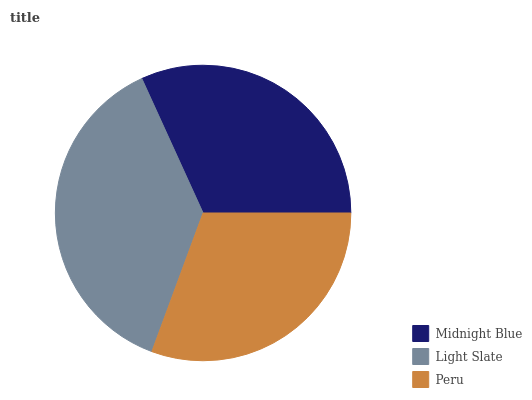Is Peru the minimum?
Answer yes or no. Yes. Is Light Slate the maximum?
Answer yes or no. Yes. Is Light Slate the minimum?
Answer yes or no. No. Is Peru the maximum?
Answer yes or no. No. Is Light Slate greater than Peru?
Answer yes or no. Yes. Is Peru less than Light Slate?
Answer yes or no. Yes. Is Peru greater than Light Slate?
Answer yes or no. No. Is Light Slate less than Peru?
Answer yes or no. No. Is Midnight Blue the high median?
Answer yes or no. Yes. Is Midnight Blue the low median?
Answer yes or no. Yes. Is Peru the high median?
Answer yes or no. No. Is Light Slate the low median?
Answer yes or no. No. 